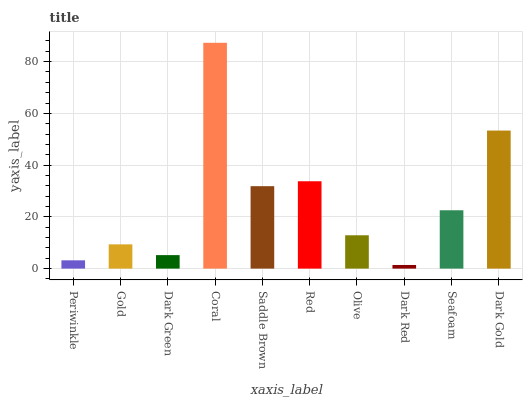Is Gold the minimum?
Answer yes or no. No. Is Gold the maximum?
Answer yes or no. No. Is Gold greater than Periwinkle?
Answer yes or no. Yes. Is Periwinkle less than Gold?
Answer yes or no. Yes. Is Periwinkle greater than Gold?
Answer yes or no. No. Is Gold less than Periwinkle?
Answer yes or no. No. Is Seafoam the high median?
Answer yes or no. Yes. Is Olive the low median?
Answer yes or no. Yes. Is Periwinkle the high median?
Answer yes or no. No. Is Dark Red the low median?
Answer yes or no. No. 